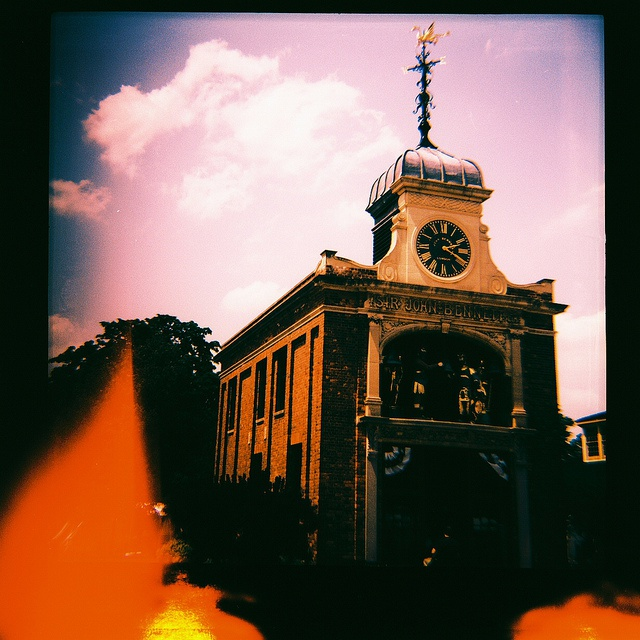Describe the objects in this image and their specific colors. I can see a clock in black, orange, red, and brown tones in this image. 